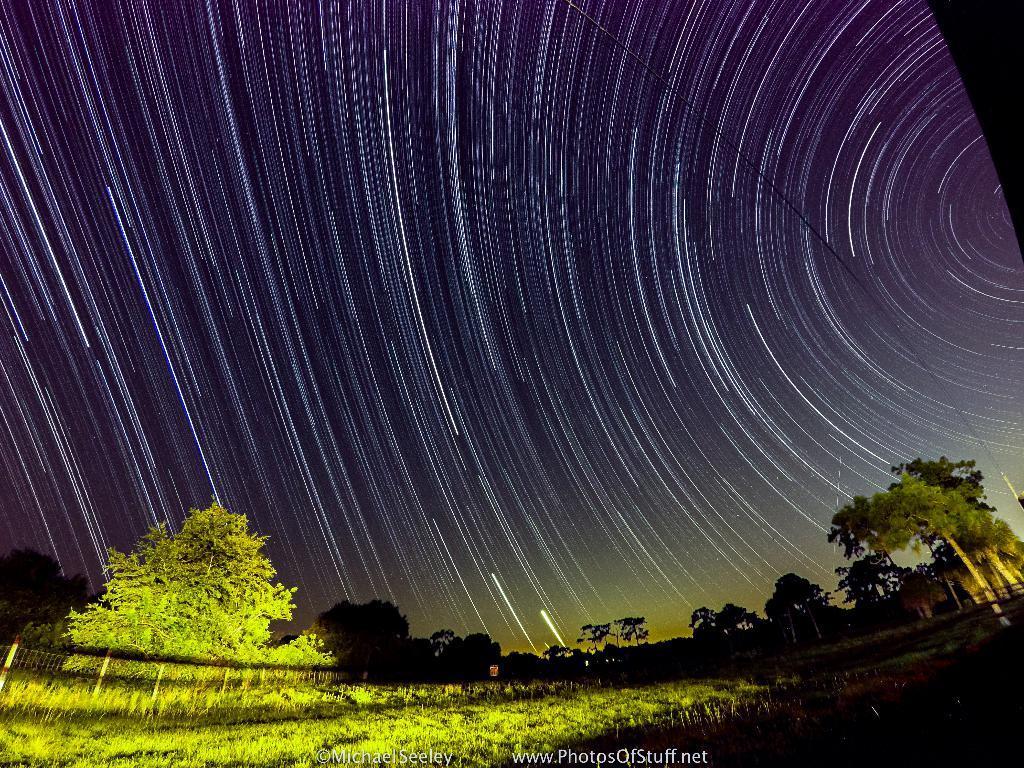Could you give a brief overview of what you see in this image? In this image we can see plants and trees. In the background there is sky. At the bottom of the image something is written. And there is a photo effect in this image. 